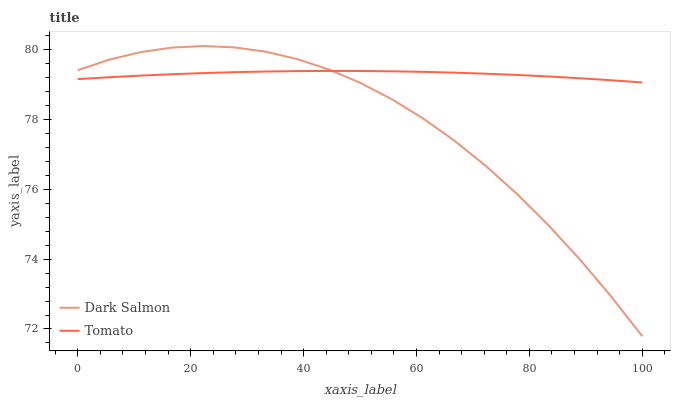Does Dark Salmon have the minimum area under the curve?
Answer yes or no. Yes. Does Tomato have the maximum area under the curve?
Answer yes or no. Yes. Does Dark Salmon have the maximum area under the curve?
Answer yes or no. No. Is Tomato the smoothest?
Answer yes or no. Yes. Is Dark Salmon the roughest?
Answer yes or no. Yes. Is Dark Salmon the smoothest?
Answer yes or no. No. Does Dark Salmon have the highest value?
Answer yes or no. Yes. Does Tomato intersect Dark Salmon?
Answer yes or no. Yes. Is Tomato less than Dark Salmon?
Answer yes or no. No. Is Tomato greater than Dark Salmon?
Answer yes or no. No. 